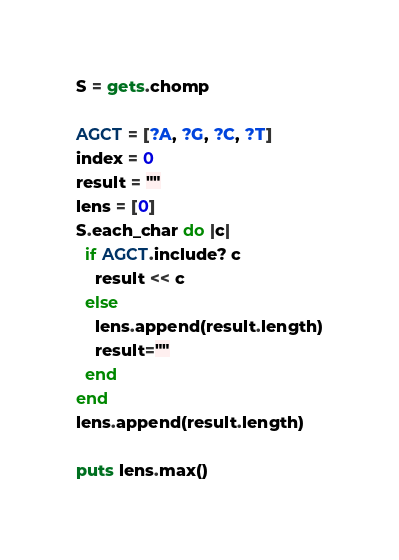Convert code to text. <code><loc_0><loc_0><loc_500><loc_500><_Ruby_>S = gets.chomp

AGCT = [?A, ?G, ?C, ?T]
index = 0
result = ""
lens = [0]
S.each_char do |c|
  if AGCT.include? c
    result << c
  else
    lens.append(result.length)
    result=""
  end
end
lens.append(result.length)

puts lens.max()
</code> 